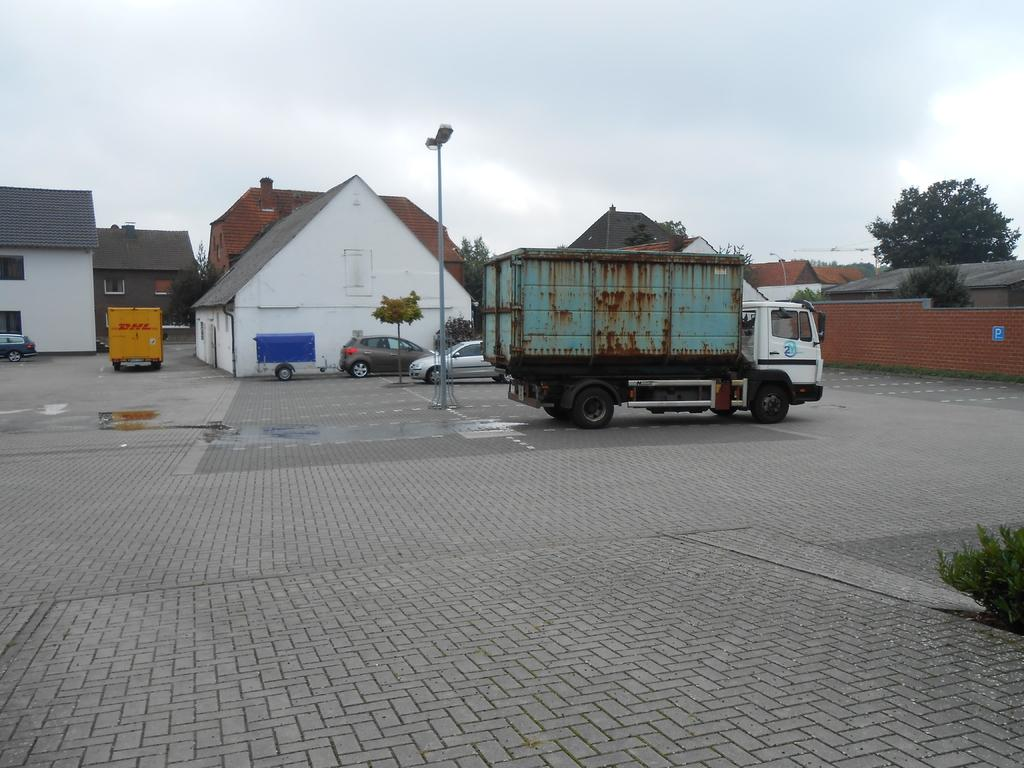What is the main object in the center of the image? There is a pole in the center of the image. What type of vehicle can be seen on the road in the image? There is a truck on the road in the image. What can be seen in the background of the image? Buildings, vehicles, trees, and the sky are visible in the background of the image. What is the condition of the sky in the image? The sky is visible in the background of the image, and clouds are present. What is located at the bottom of the image? There is a plant at the bottom of the image. What type of surface is present in the image? There is a floor in the image. What type of hair can be seen on the pole in the image? There is no hair present on the pole in the image; it is a pole without any hair-like features. 